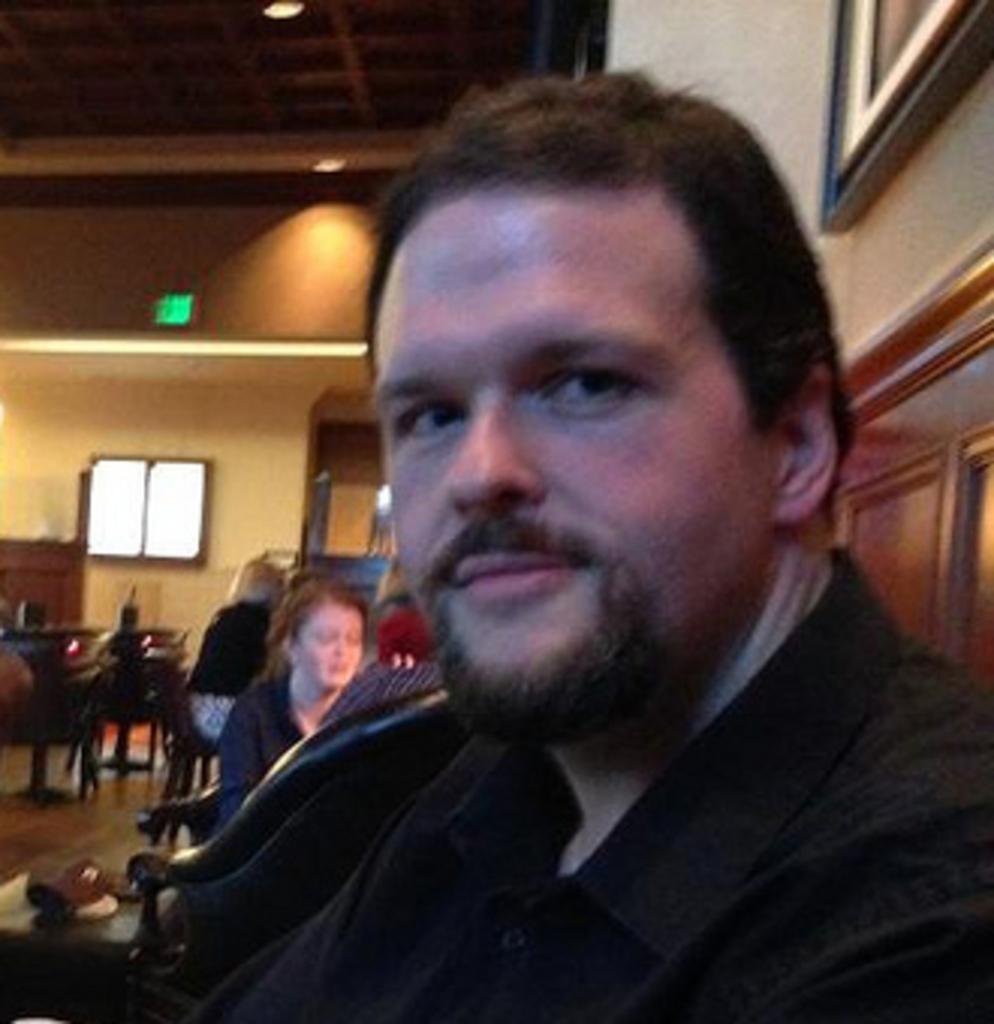Please provide a concise description of this image. This image consists of a man wearing a black shirt. It looks like a restaurant. In the background, we can see many people. And we can see tables and chairs. At the top, there is a roof along with the light. On the right, there is a frame on the wall. At the bottom, there is a floor. 